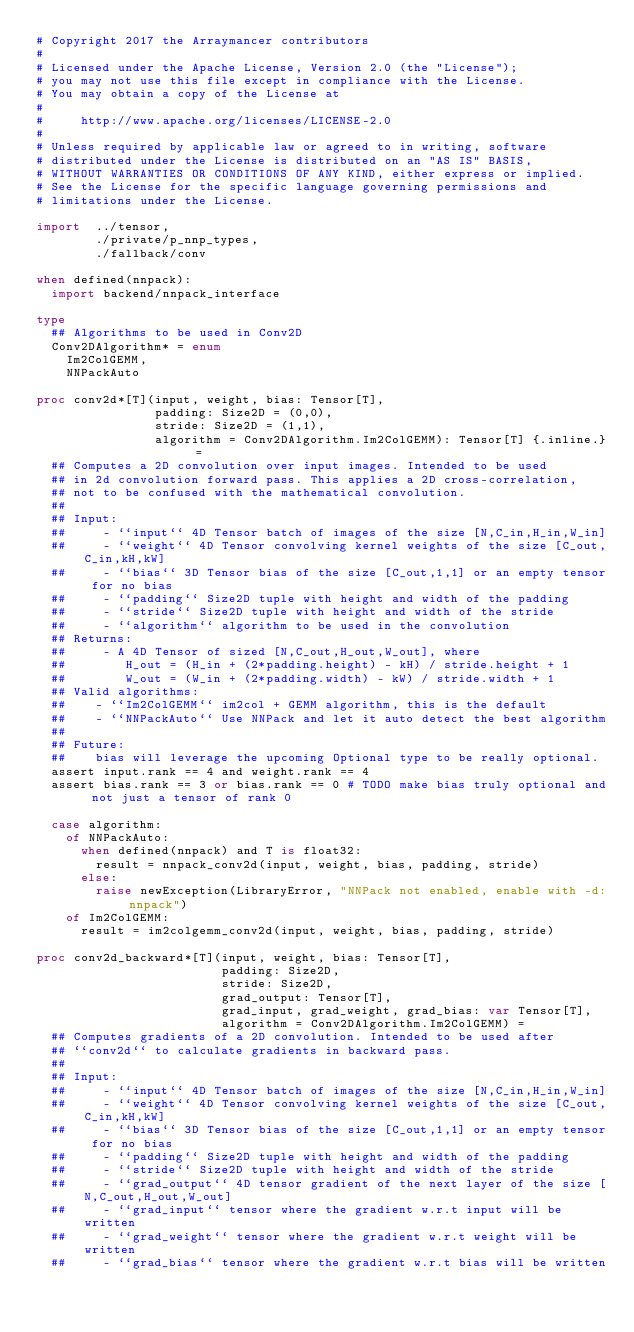<code> <loc_0><loc_0><loc_500><loc_500><_Nim_># Copyright 2017 the Arraymancer contributors
#
# Licensed under the Apache License, Version 2.0 (the "License");
# you may not use this file except in compliance with the License.
# You may obtain a copy of the License at
#
#     http://www.apache.org/licenses/LICENSE-2.0
#
# Unless required by applicable law or agreed to in writing, software
# distributed under the License is distributed on an "AS IS" BASIS,
# WITHOUT WARRANTIES OR CONDITIONS OF ANY KIND, either express or implied.
# See the License for the specific language governing permissions and
# limitations under the License.

import  ../tensor,
        ./private/p_nnp_types,
        ./fallback/conv

when defined(nnpack):
  import backend/nnpack_interface

type
  ## Algorithms to be used in Conv2D
  Conv2DAlgorithm* = enum
    Im2ColGEMM,
    NNPackAuto

proc conv2d*[T](input, weight, bias: Tensor[T],
                padding: Size2D = (0,0),
                stride: Size2D = (1,1),
                algorithm = Conv2DAlgorithm.Im2ColGEMM): Tensor[T] {.inline.} =
  ## Computes a 2D convolution over input images. Intended to be used
  ## in 2d convolution forward pass. This applies a 2D cross-correlation,
  ## not to be confused with the mathematical convolution.
  ##
  ## Input:
  ##     - ``input`` 4D Tensor batch of images of the size [N,C_in,H_in,W_in]
  ##     - ``weight`` 4D Tensor convolving kernel weights of the size [C_out,C_in,kH,kW]
  ##     - ``bias`` 3D Tensor bias of the size [C_out,1,1] or an empty tensor for no bias
  ##     - ``padding`` Size2D tuple with height and width of the padding
  ##     - ``stride`` Size2D tuple with height and width of the stride
  ##     - ``algorithm`` algorithm to be used in the convolution
  ## Returns:
  ##     - A 4D Tensor of sized [N,C_out,H_out,W_out], where
  ##        H_out = (H_in + (2*padding.height) - kH) / stride.height + 1
  ##        W_out = (W_in + (2*padding.width) - kW) / stride.width + 1
  ## Valid algorithms:
  ##    - ``Im2ColGEMM`` im2col + GEMM algorithm, this is the default
  ##    - ``NNPackAuto`` Use NNPack and let it auto detect the best algorithm
  ##
  ## Future:
  ##    bias will leverage the upcoming Optional type to be really optional.
  assert input.rank == 4 and weight.rank == 4
  assert bias.rank == 3 or bias.rank == 0 # TODO make bias truly optional and not just a tensor of rank 0

  case algorithm:
    of NNPackAuto:
      when defined(nnpack) and T is float32:
        result = nnpack_conv2d(input, weight, bias, padding, stride)
      else:
        raise newException(LibraryError, "NNPack not enabled, enable with -d:nnpack")
    of Im2ColGEMM:
      result = im2colgemm_conv2d(input, weight, bias, padding, stride)

proc conv2d_backward*[T](input, weight, bias: Tensor[T],
                         padding: Size2D,
                         stride: Size2D,
                         grad_output: Tensor[T],
                         grad_input, grad_weight, grad_bias: var Tensor[T],
                         algorithm = Conv2DAlgorithm.Im2ColGEMM) =
  ## Computes gradients of a 2D convolution. Intended to be used after
  ## ``conv2d`` to calculate gradients in backward pass.
  ##
  ## Input:
  ##     - ``input`` 4D Tensor batch of images of the size [N,C_in,H_in,W_in]
  ##     - ``weight`` 4D Tensor convolving kernel weights of the size [C_out,C_in,kH,kW]
  ##     - ``bias`` 3D Tensor bias of the size [C_out,1,1] or an empty tensor for no bias
  ##     - ``padding`` Size2D tuple with height and width of the padding
  ##     - ``stride`` Size2D tuple with height and width of the stride
  ##     - ``grad_output`` 4D tensor gradient of the next layer of the size [N,C_out,H_out,W_out]
  ##     - ``grad_input`` tensor where the gradient w.r.t input will be written
  ##     - ``grad_weight`` tensor where the gradient w.r.t weight will be written
  ##     - ``grad_bias`` tensor where the gradient w.r.t bias will be written</code> 